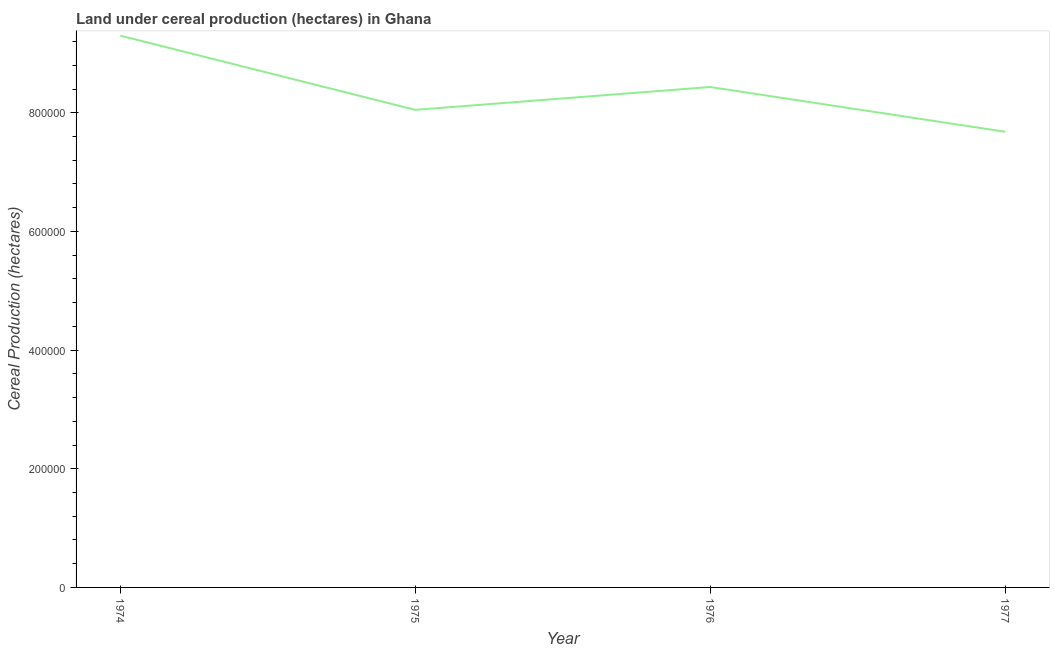What is the land under cereal production in 1975?
Your answer should be compact. 8.05e+05. Across all years, what is the maximum land under cereal production?
Give a very brief answer. 9.30e+05. Across all years, what is the minimum land under cereal production?
Make the answer very short. 7.68e+05. In which year was the land under cereal production maximum?
Make the answer very short. 1974. What is the sum of the land under cereal production?
Offer a terse response. 3.35e+06. What is the difference between the land under cereal production in 1974 and 1977?
Provide a succinct answer. 1.62e+05. What is the average land under cereal production per year?
Offer a very short reply. 8.37e+05. What is the median land under cereal production?
Provide a succinct answer. 8.24e+05. In how many years, is the land under cereal production greater than 720000 hectares?
Offer a terse response. 4. What is the ratio of the land under cereal production in 1974 to that in 1976?
Give a very brief answer. 1.1. What is the difference between the highest and the second highest land under cereal production?
Your response must be concise. 8.66e+04. Is the sum of the land under cereal production in 1974 and 1976 greater than the maximum land under cereal production across all years?
Provide a short and direct response. Yes. What is the difference between the highest and the lowest land under cereal production?
Give a very brief answer. 1.62e+05. Does the land under cereal production monotonically increase over the years?
Your response must be concise. No. How many years are there in the graph?
Provide a short and direct response. 4. What is the difference between two consecutive major ticks on the Y-axis?
Provide a short and direct response. 2.00e+05. What is the title of the graph?
Offer a terse response. Land under cereal production (hectares) in Ghana. What is the label or title of the X-axis?
Provide a succinct answer. Year. What is the label or title of the Y-axis?
Offer a very short reply. Cereal Production (hectares). What is the Cereal Production (hectares) in 1974?
Your answer should be compact. 9.30e+05. What is the Cereal Production (hectares) in 1975?
Make the answer very short. 8.05e+05. What is the Cereal Production (hectares) in 1976?
Your answer should be very brief. 8.43e+05. What is the Cereal Production (hectares) of 1977?
Provide a succinct answer. 7.68e+05. What is the difference between the Cereal Production (hectares) in 1974 and 1975?
Your answer should be very brief. 1.25e+05. What is the difference between the Cereal Production (hectares) in 1974 and 1976?
Your answer should be compact. 8.66e+04. What is the difference between the Cereal Production (hectares) in 1974 and 1977?
Provide a short and direct response. 1.62e+05. What is the difference between the Cereal Production (hectares) in 1975 and 1976?
Make the answer very short. -3.85e+04. What is the difference between the Cereal Production (hectares) in 1975 and 1977?
Offer a very short reply. 3.69e+04. What is the difference between the Cereal Production (hectares) in 1976 and 1977?
Make the answer very short. 7.54e+04. What is the ratio of the Cereal Production (hectares) in 1974 to that in 1975?
Offer a very short reply. 1.16. What is the ratio of the Cereal Production (hectares) in 1974 to that in 1976?
Give a very brief answer. 1.1. What is the ratio of the Cereal Production (hectares) in 1974 to that in 1977?
Keep it short and to the point. 1.21. What is the ratio of the Cereal Production (hectares) in 1975 to that in 1976?
Ensure brevity in your answer.  0.95. What is the ratio of the Cereal Production (hectares) in 1975 to that in 1977?
Provide a succinct answer. 1.05. What is the ratio of the Cereal Production (hectares) in 1976 to that in 1977?
Your response must be concise. 1.1. 